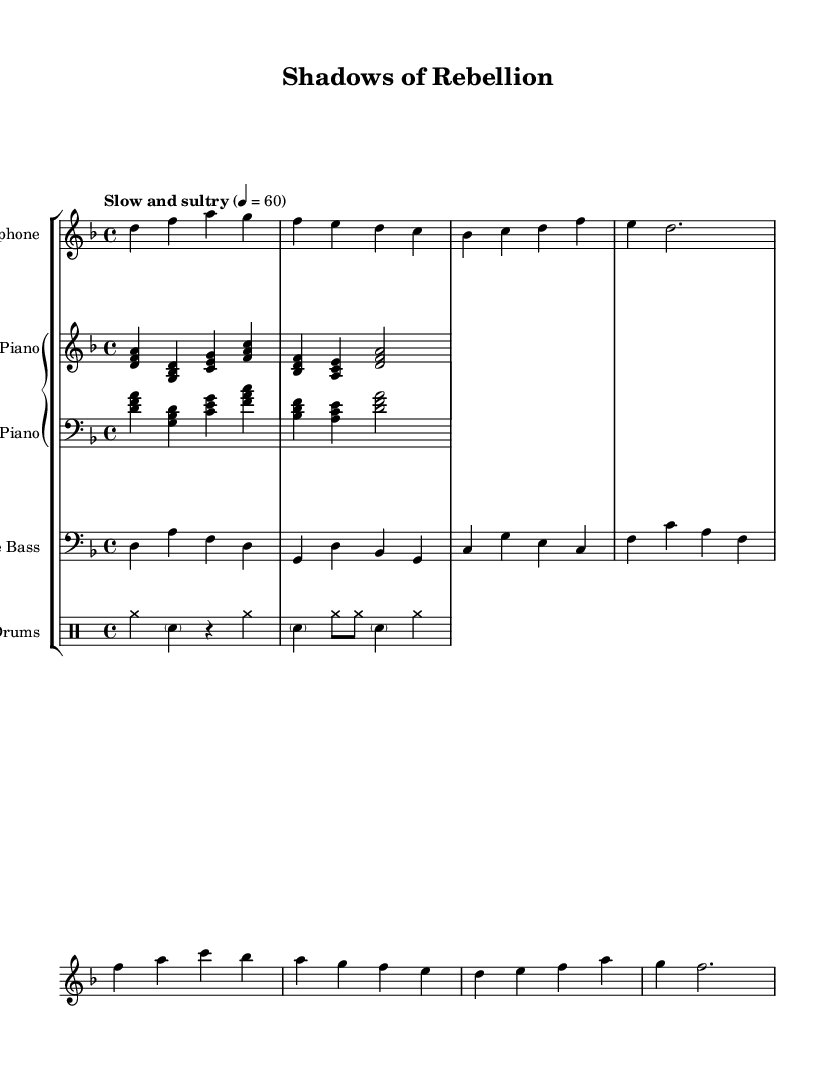What is the key signature of this music? The key signature indicates the notes that will be sharp or flat throughout the piece. In the score, it shows one flat (B♭). Therefore, the key signature is D minor.
Answer: D minor What is the time signature of this music? Time signature tells you how many beats are in each measure and what note value counts as one beat. In this score, it shows a 4 over 4, meaning there are four quarter note beats in each measure.
Answer: 4/4 What is the tempo marking for this piece? The tempo marking gives you the speed of the piece. In the score, it states "Slow and sultry" with a metronome marking of 60, indicating the tempo is slow played at 60 beats per minute.
Answer: Slow and sultry How many measures are in the saxophone part? By counting the measures in the saxophone staff from the beginning to the end, we see there are a total of 8 measures in the saxophone part.
Answer: 8 What instrument plays the bass line? The bass line is indicated by the staff labeled with the clef typically associated with bass instruments, which is the double bass in this case.
Answer: Double Bass Which instruments are involved in this piece? Looking at the staff groupings, the instruments present are the saxophone, piano, double bass, and drums, all indicated by the respective staff labels.
Answer: Saxophone, Piano, Double Bass, Drums What type of jazz does this music evoke? Considering the title "Shadows of Rebellion" and the context of the music, it suggests themes of smoky jazz noir associated with underground resistance. This indicates a style that is reflective of secretive and haunting atmospheres typical of jazz noir.
Answer: Jazz noir 